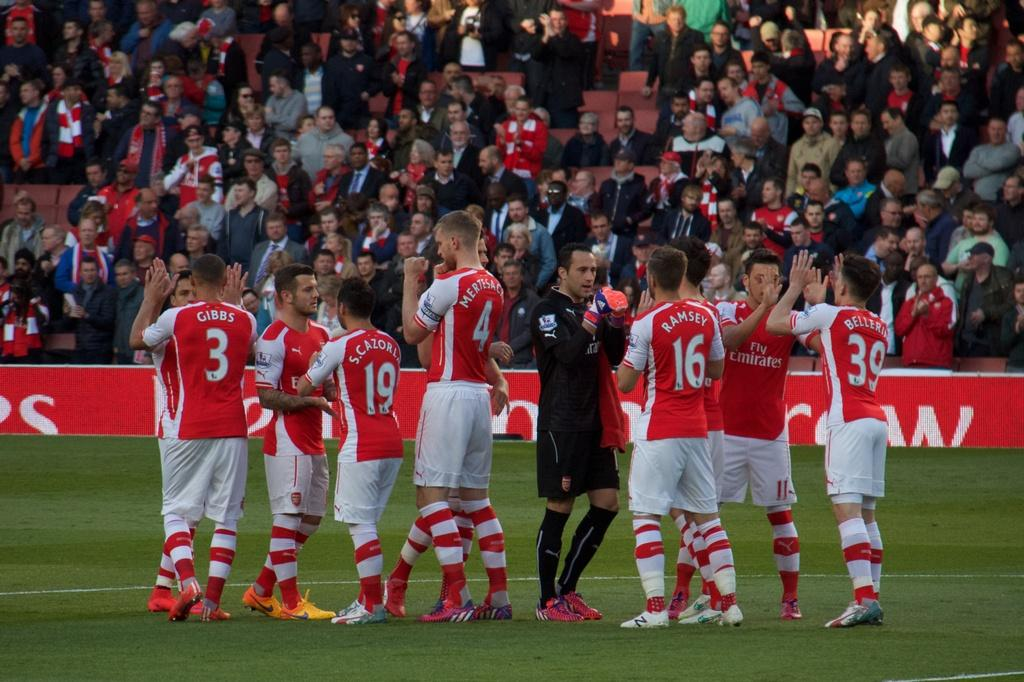<image>
Provide a brief description of the given image. Players from the Fly Emirates sports team are celebrating on the field. 